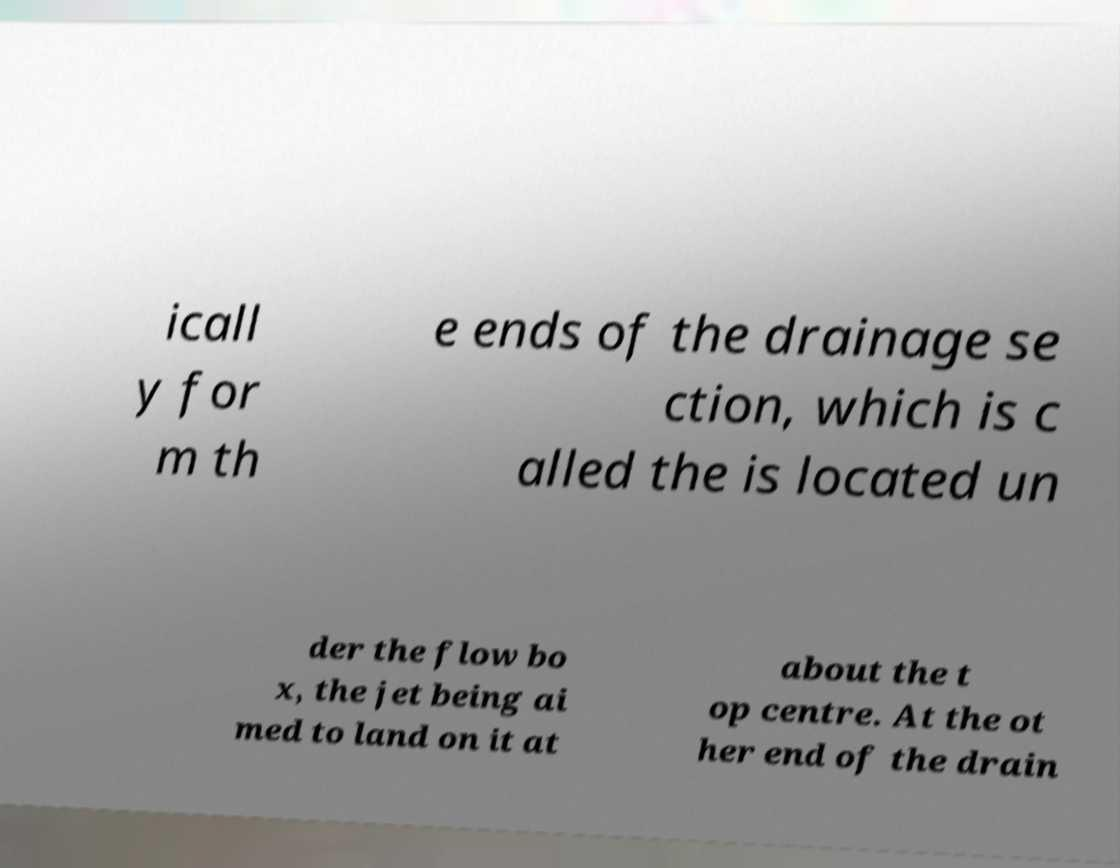Can you accurately transcribe the text from the provided image for me? icall y for m th e ends of the drainage se ction, which is c alled the is located un der the flow bo x, the jet being ai med to land on it at about the t op centre. At the ot her end of the drain 